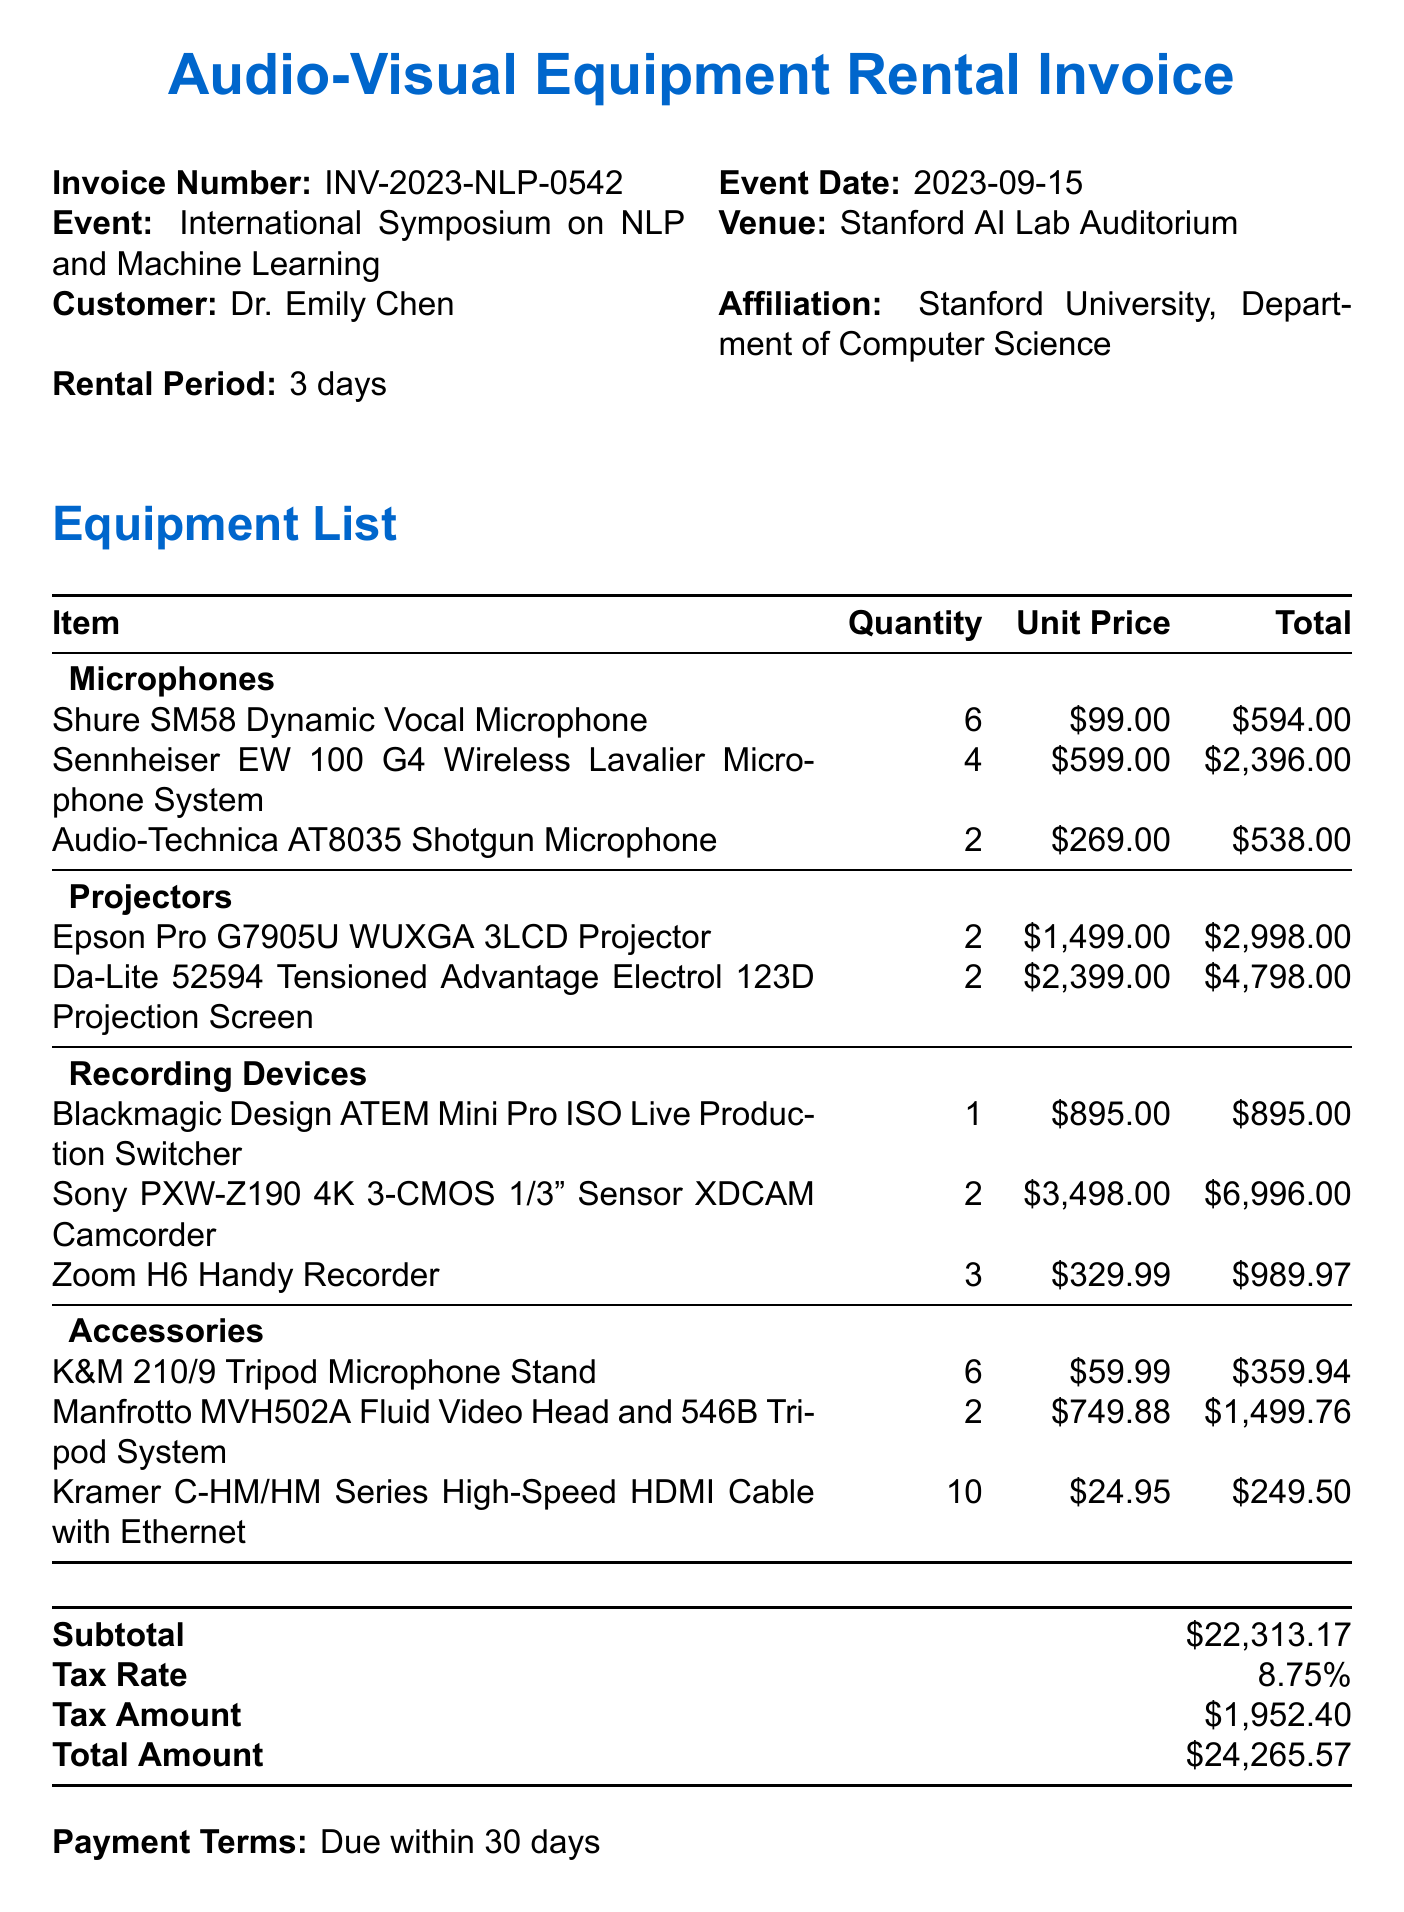What is the invoice number? The invoice number can be found at the top of the document, which specifies the unique identifier for the rental.
Answer: INV-2023-NLP-0542 Who is the customer? The customer's name is listed in the document, which identifies the individual renting the equipment.
Answer: Dr. Emily Chen What is the total amount due? The total amount due is provided in the summary section at the end of the invoice.
Answer: $24,265.57 How many Sennheiser microphones were rented? The number of Sennheiser microphones can be found under the Microphones category in the equipment list.
Answer: 4 What is the rental period? The rental period is specified in the invoice, indicating how long the equipment will be rented.
Answer: 3 days What type of projector is listed? The specific type of projector can be found in the Projectors section of the invoice.
Answer: Epson Pro G7905U WUXGA 3LCD Projector What special instructions were given? The special instructions detail specific tasks related to the setup of the rented equipment before the event.
Answer: Please ensure all equipment is set up and tested by September 14th, 2023, for the pre-symposium technical check How many Sony camcorders are included? The number of Sony camcorders can be identified in the Recording Devices section of the invoice.
Answer: 2 What is the tax rate applied to the rental? The tax rate is provided in the summary section, detailing the percentage applied to the subtotal.
Answer: 8.75% 